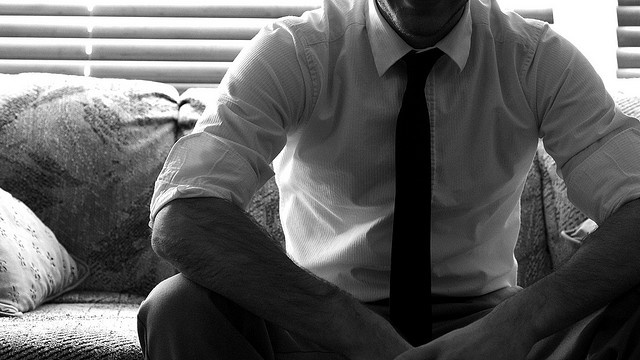Describe the objects in this image and their specific colors. I can see people in black, white, gray, darkgray, and lightgray tones, couch in white, black, gray, and darkgray tones, and tie in black and white tones in this image. 